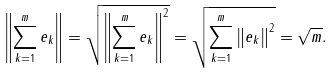Convert formula to latex. <formula><loc_0><loc_0><loc_500><loc_500>\left \| \sum _ { k = 1 } ^ { m } e _ { k } \right \| = \sqrt { \left \| \sum _ { k = 1 } ^ { m } e _ { k } \right \| ^ { 2 } } = \sqrt { \sum _ { k = 1 } ^ { m } \left \| e _ { k } \right \| ^ { 2 } } = \sqrt { m } .</formula> 